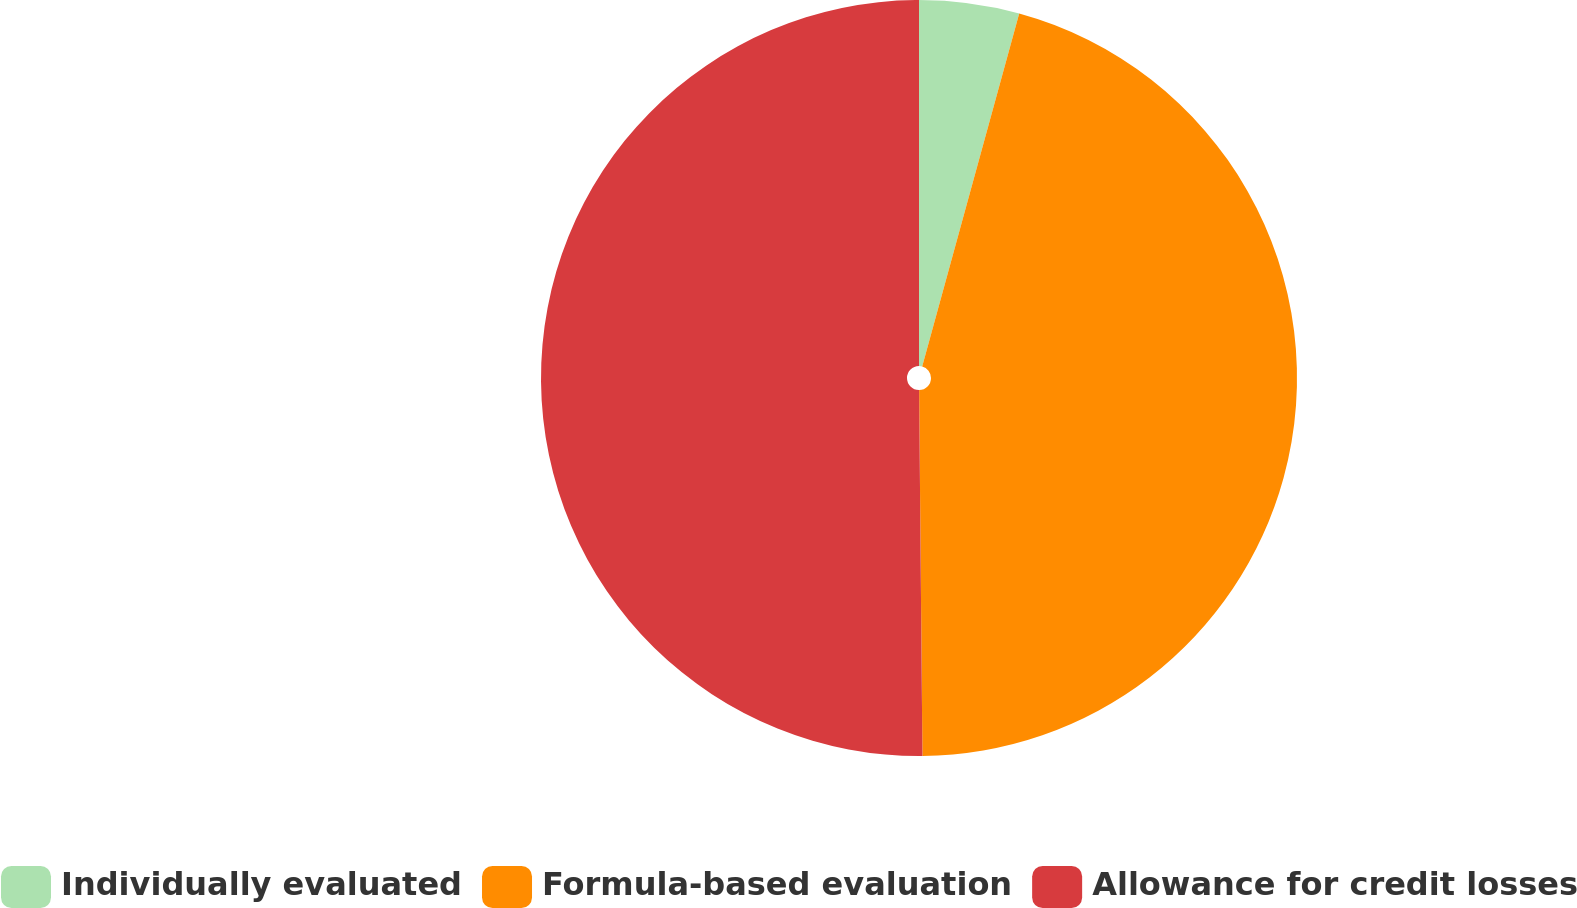Convert chart to OTSL. <chart><loc_0><loc_0><loc_500><loc_500><pie_chart><fcel>Individually evaluated<fcel>Formula-based evaluation<fcel>Allowance for credit losses<nl><fcel>4.27%<fcel>45.58%<fcel>50.14%<nl></chart> 